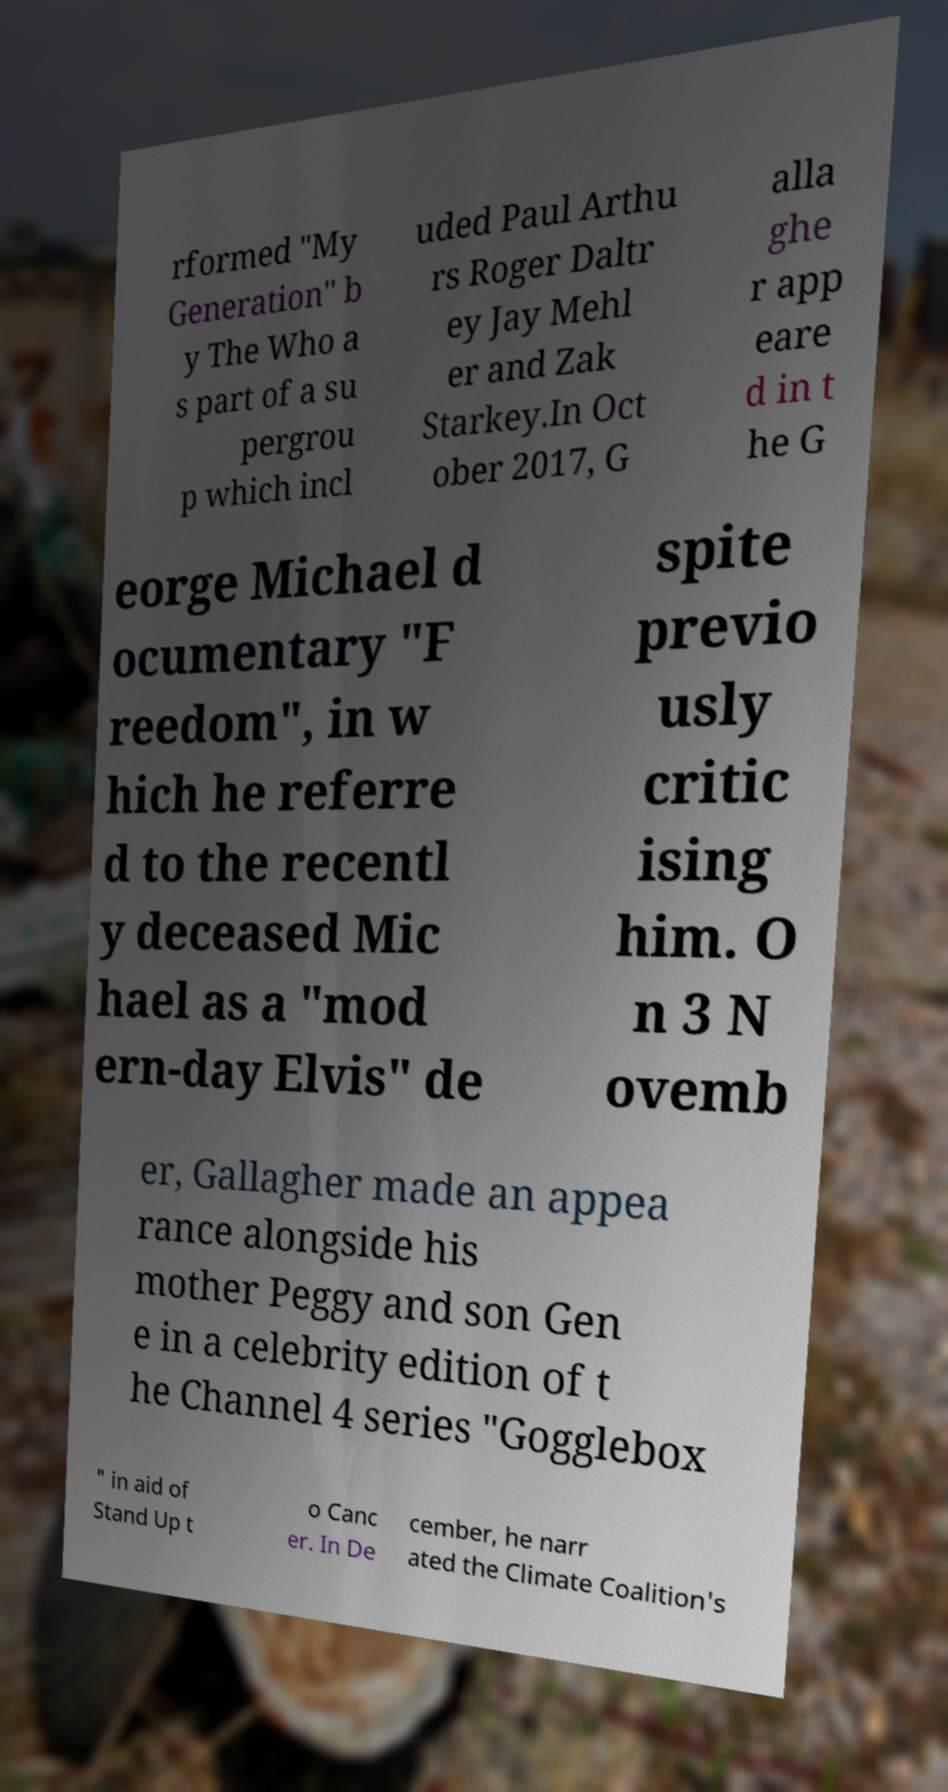Could you extract and type out the text from this image? rformed "My Generation" b y The Who a s part of a su pergrou p which incl uded Paul Arthu rs Roger Daltr ey Jay Mehl er and Zak Starkey.In Oct ober 2017, G alla ghe r app eare d in t he G eorge Michael d ocumentary "F reedom", in w hich he referre d to the recentl y deceased Mic hael as a "mod ern-day Elvis" de spite previo usly critic ising him. O n 3 N ovemb er, Gallagher made an appea rance alongside his mother Peggy and son Gen e in a celebrity edition of t he Channel 4 series "Gogglebox " in aid of Stand Up t o Canc er. In De cember, he narr ated the Climate Coalition's 